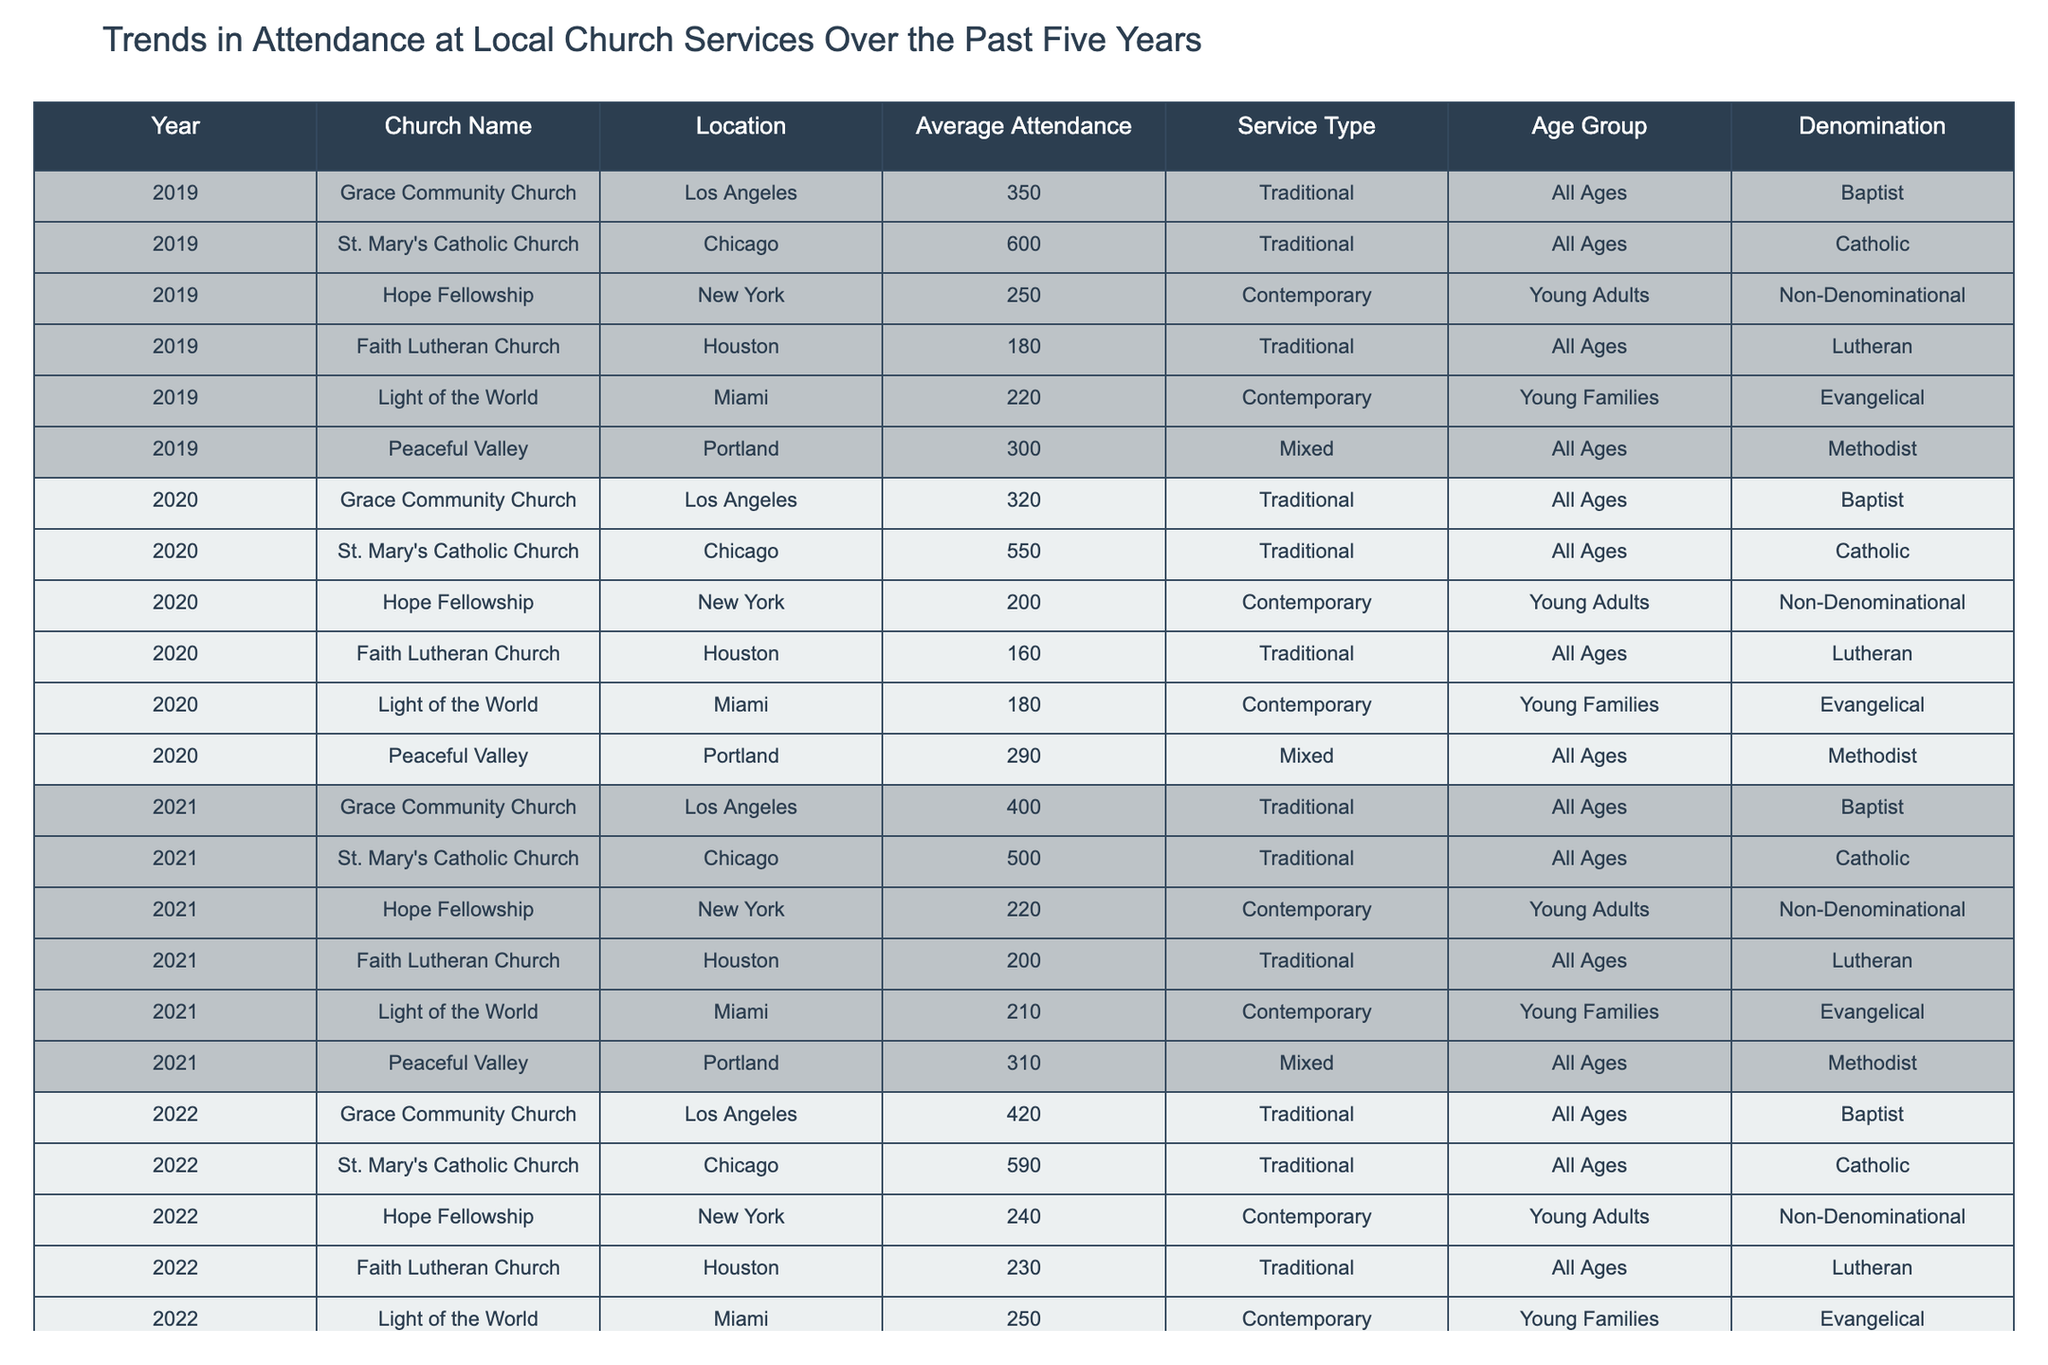What was the average attendance at St. Mary's Catholic Church in 2022? The attendance for St. Mary's Catholic Church in 2022 was 590, as shown in the table.
Answer: 590 Which church had the highest average attendance in 2023? In 2023, St. Mary's Catholic Church had the highest average attendance with 610.
Answer: 610 How much did the average attendance at Hope Fellowship decrease from 2019 to 2020? In 2019, Hope Fellowship had an attendance of 250, and in 2020, it decreased to 200. The decrease is calculated as 250 - 200 = 50.
Answer: 50 What is the total average attendance at Faith Lutheran Church from 2019 to 2023? The attendances are 180 (2019), 160 (2020), 200 (2021), 230 (2022), and 240 (2023). Summing these gives 180 + 160 + 200 + 230 + 240 = 1,010, and dividing by 5 gives an average of 1,010 / 5 = 202.
Answer: 202 Did the attendance at Grace Community Church increase every year from 2019 to 2023? Taking the yearly attendances (350, 320, 400, 420, 450), we see that there was a decrease from 2019 to 2020 (350 to 320). Thus, the attendance did not increase every year.
Answer: No What was the percentage increase in attendance at Light of the World from 2019 to 2023? In 2019, the attendance was 220, and in 2023, it was 280. The increase is 280 - 220 = 60. The percentage increase is calculated as (60 / 220) * 100 = 27.27%.
Answer: 27.27% Which age group had the highest average attendance across all churches in 2023? In 2023, attendance data for age groups shows that all ages for St. Mary's Catholic Church had the highest single attendance figure of 610, while all others were lower. Therefore, the highest average attendance across all age groups is for All Ages.
Answer: All Ages What is the trend for average attendance in Peaceful Valley Church from 2020 to 2023? The attendances are 290 (2020), 310 (2021), 320 (2022), and 340 (2023). The values indicate a steady increase each year, confirming a positive trend.
Answer: Positive trend How does the attendance at the evangelical Light of the World compare to average attendance in the traditional churches in 2023? In 2023, Light of the World had an attendance of 280, while traditional churches like St. Mary's had 610, Grace Community had 450, Faith Lutheran had 240, and Peaceful Valley had 340. The average attendance for traditional churches is (610 + 450 + 240 + 340) / 4 = 410. Light of the World’s attendance is lower than this average.
Answer: Lower than average Which church's attendance fluctuated the most from 2019 to 2023? Comparing each church, Hope Fellowship’s attendance in 2019 was 250 and in 2023 it was 260, showing limited fluctuation. However, St. Mary's went from 600 to 610, with minimal change. Reviewing all, Grace Community Church experienced an increase from 350 in 2019 to 450 in 2023, reflecting the most significant fluctuation overall.
Answer: Grace Community Church 